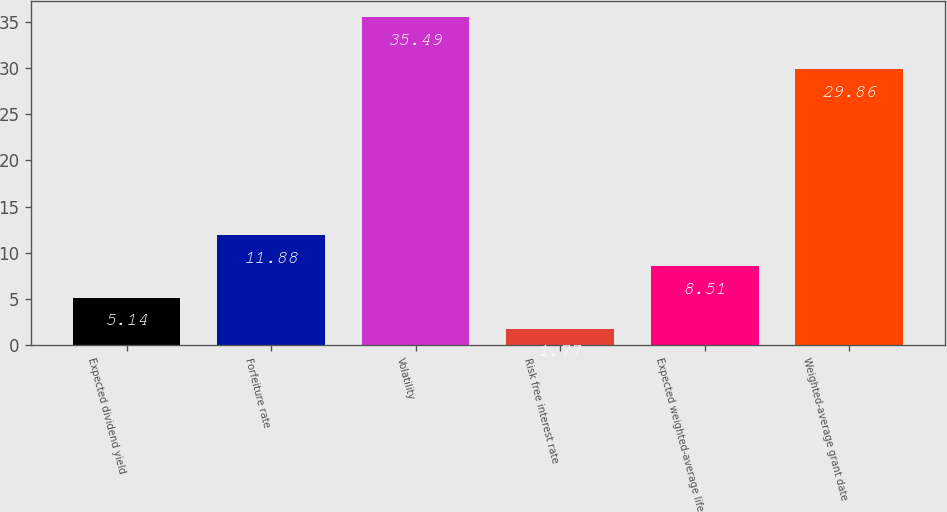Convert chart. <chart><loc_0><loc_0><loc_500><loc_500><bar_chart><fcel>Expected dividend yield<fcel>Forfeiture rate<fcel>Volatility<fcel>Risk free interest rate<fcel>Expected weighted-average life<fcel>Weighted-average grant date<nl><fcel>5.14<fcel>11.88<fcel>35.49<fcel>1.77<fcel>8.51<fcel>29.86<nl></chart> 